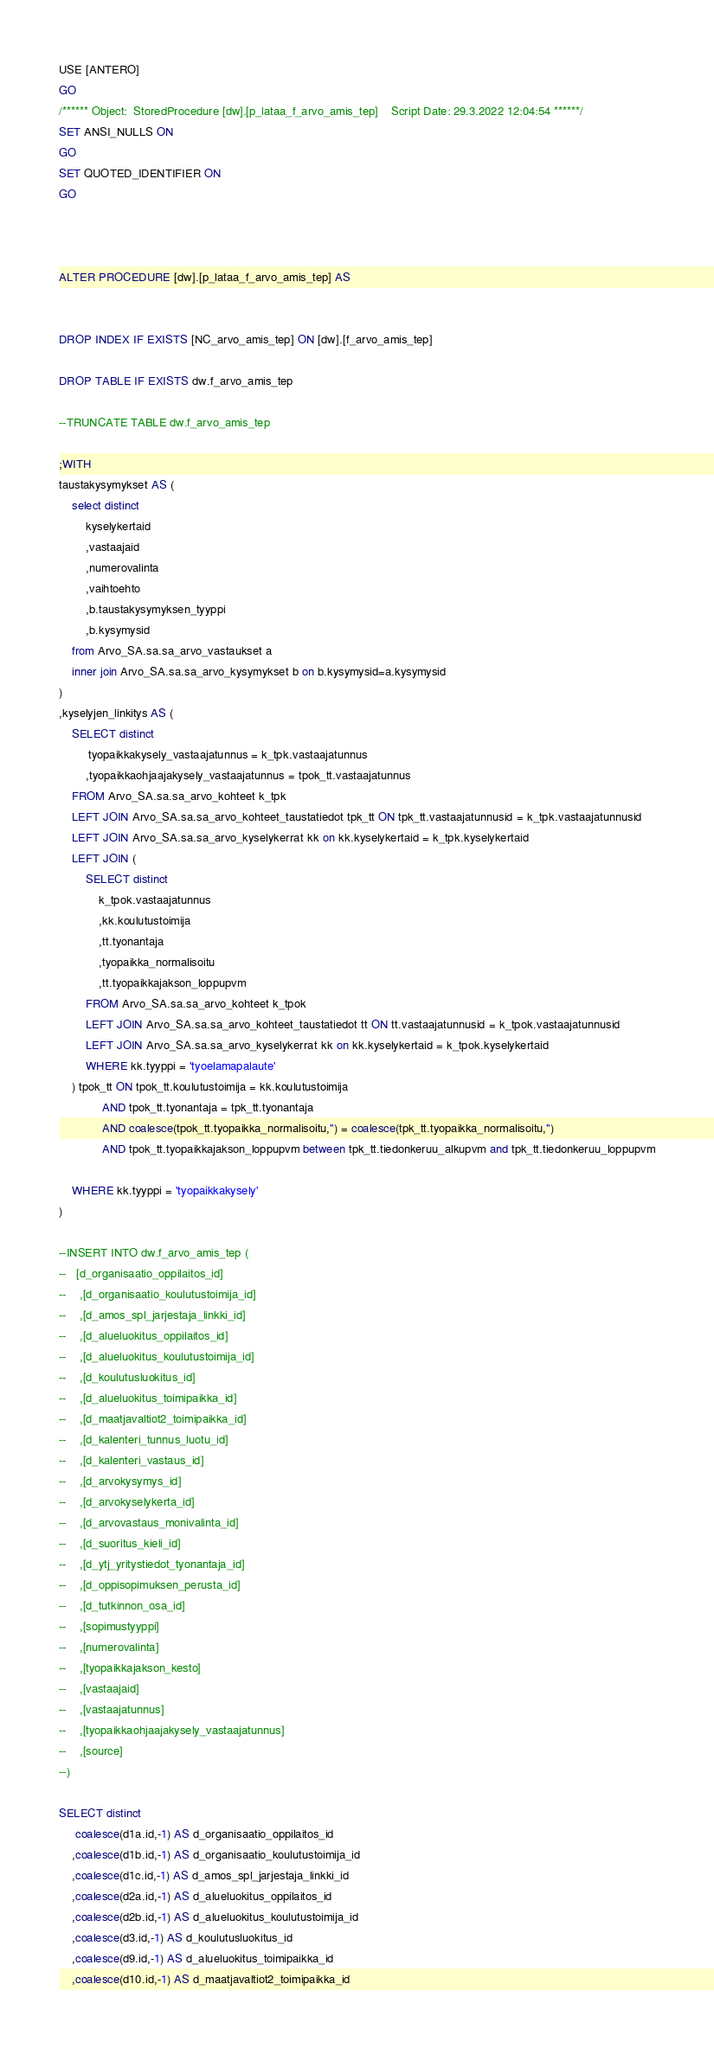Convert code to text. <code><loc_0><loc_0><loc_500><loc_500><_SQL_>USE [ANTERO]
GO
/****** Object:  StoredProcedure [dw].[p_lataa_f_arvo_amis_tep]    Script Date: 29.3.2022 12:04:54 ******/
SET ANSI_NULLS ON
GO
SET QUOTED_IDENTIFIER ON
GO



ALTER PROCEDURE [dw].[p_lataa_f_arvo_amis_tep] AS


DROP INDEX IF EXISTS [NC_arvo_amis_tep] ON [dw].[f_arvo_amis_tep]

DROP TABLE IF EXISTS dw.f_arvo_amis_tep

--TRUNCATE TABLE dw.f_arvo_amis_tep

;WITH 
taustakysymykset AS (
	select distinct 
		kyselykertaid
		,vastaajaid
		,numerovalinta
		,vaihtoehto
		,b.taustakysymyksen_tyyppi
		,b.kysymysid
	from Arvo_SA.sa.sa_arvo_vastaukset a 
	inner join Arvo_SA.sa.sa_arvo_kysymykset b on b.kysymysid=a.kysymysid 
)
,kyselyjen_linkitys AS (
	SELECT distinct 
		 tyopaikkakysely_vastaajatunnus = k_tpk.vastaajatunnus
		,tyopaikkaohjaajakysely_vastaajatunnus = tpok_tt.vastaajatunnus
	FROM Arvo_SA.sa.sa_arvo_kohteet k_tpk
	LEFT JOIN Arvo_SA.sa.sa_arvo_kohteet_taustatiedot tpk_tt ON tpk_tt.vastaajatunnusid = k_tpk.vastaajatunnusid
	LEFT JOIN Arvo_SA.sa.sa_arvo_kyselykerrat kk on kk.kyselykertaid = k_tpk.kyselykertaid
	LEFT JOIN (
		SELECT distinct
			k_tpok.vastaajatunnus
			,kk.koulutustoimija
			,tt.tyonantaja
			,tyopaikka_normalisoitu
			,tt.tyopaikkajakson_loppupvm
		FROM Arvo_SA.sa.sa_arvo_kohteet k_tpok
		LEFT JOIN Arvo_SA.sa.sa_arvo_kohteet_taustatiedot tt ON tt.vastaajatunnusid = k_tpok.vastaajatunnusid
		LEFT JOIN Arvo_SA.sa.sa_arvo_kyselykerrat kk on kk.kyselykertaid = k_tpok.kyselykertaid
		WHERE kk.tyyppi = 'tyoelamapalaute'
	) tpok_tt ON tpok_tt.koulutustoimija = kk.koulutustoimija
			 AND tpok_tt.tyonantaja = tpk_tt.tyonantaja
			 AND coalesce(tpok_tt.tyopaikka_normalisoitu,'') = coalesce(tpk_tt.tyopaikka_normalisoitu,'')
			 AND tpok_tt.tyopaikkajakson_loppupvm between tpk_tt.tiedonkeruu_alkupvm and tpk_tt.tiedonkeruu_loppupvm

	WHERE kk.tyyppi = 'tyopaikkakysely'
)

--INSERT INTO dw.f_arvo_amis_tep (
--	 [d_organisaatio_oppilaitos_id]
--    ,[d_organisaatio_koulutustoimija_id]
--    ,[d_amos_spl_jarjestaja_linkki_id]
--    ,[d_alueluokitus_oppilaitos_id]
--    ,[d_alueluokitus_koulutustoimija_id]
--    ,[d_koulutusluokitus_id]
--    ,[d_alueluokitus_toimipaikka_id]
--    ,[d_maatjavaltiot2_toimipaikka_id]
--    ,[d_kalenteri_tunnus_luotu_id]
--    ,[d_kalenteri_vastaus_id]
--    ,[d_arvokysymys_id]
--    ,[d_arvokyselykerta_id]
--    ,[d_arvovastaus_monivalinta_id]
--    ,[d_suoritus_kieli_id]
--    ,[d_ytj_yritystiedot_tyonantaja_id]
--    ,[d_oppisopimuksen_perusta_id]
--    ,[d_tutkinnon_osa_id]
--    ,[sopimustyyppi]
--    ,[numerovalinta]
--    ,[tyopaikkajakson_kesto]
--    ,[vastaajaid]
--    ,[vastaajatunnus]
--    ,[tyopaikkaohjaajakysely_vastaajatunnus]
--    ,[source]
--)

SELECT distinct
     coalesce(d1a.id,-1) AS d_organisaatio_oppilaitos_id
	,coalesce(d1b.id,-1) AS d_organisaatio_koulutustoimija_id
	,coalesce(d1c.id,-1) AS d_amos_spl_jarjestaja_linkki_id
	,coalesce(d2a.id,-1) AS d_alueluokitus_oppilaitos_id
	,coalesce(d2b.id,-1) AS d_alueluokitus_koulutustoimija_id
	,coalesce(d3.id,-1) AS d_koulutusluokitus_id
	,coalesce(d9.id,-1) AS d_alueluokitus_toimipaikka_id
	,coalesce(d10.id,-1) AS d_maatjavaltiot2_toimipaikka_id</code> 